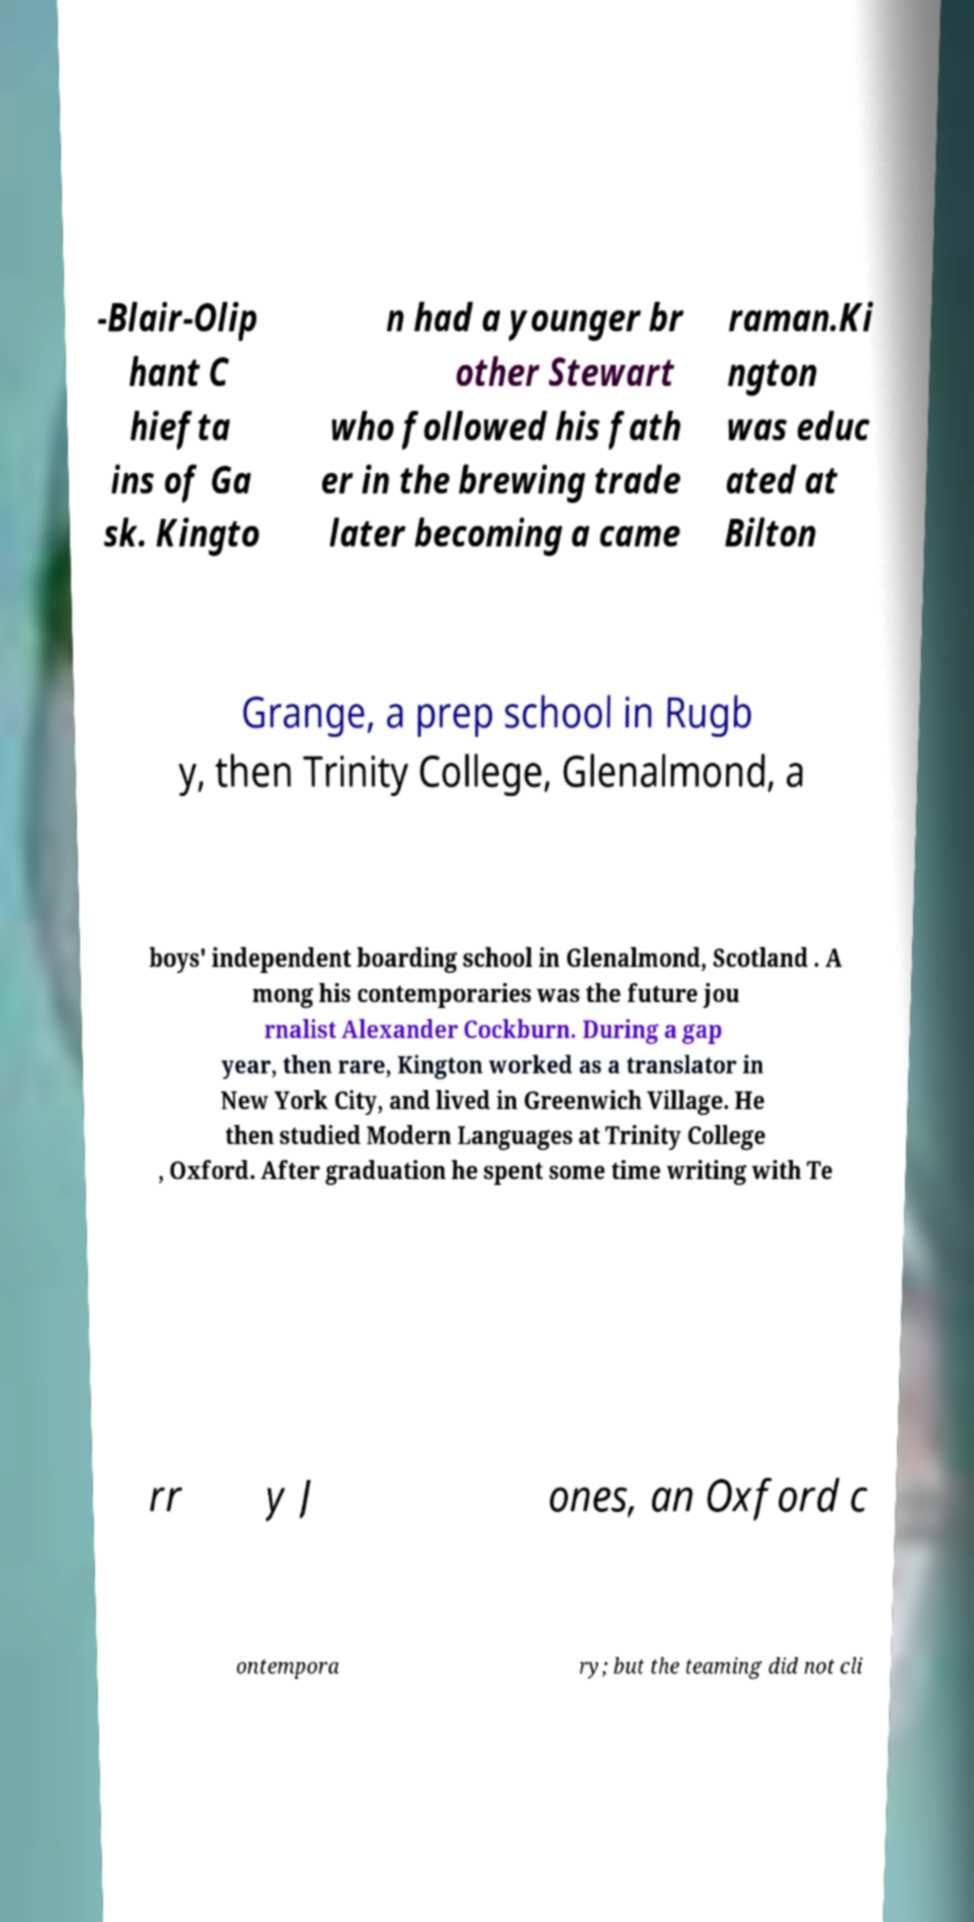Can you accurately transcribe the text from the provided image for me? -Blair-Olip hant C hiefta ins of Ga sk. Kingto n had a younger br other Stewart who followed his fath er in the brewing trade later becoming a came raman.Ki ngton was educ ated at Bilton Grange, a prep school in Rugb y, then Trinity College, Glenalmond, a boys' independent boarding school in Glenalmond, Scotland . A mong his contemporaries was the future jou rnalist Alexander Cockburn. During a gap year, then rare, Kington worked as a translator in New York City, and lived in Greenwich Village. He then studied Modern Languages at Trinity College , Oxford. After graduation he spent some time writing with Te rr y J ones, an Oxford c ontempora ry; but the teaming did not cli 